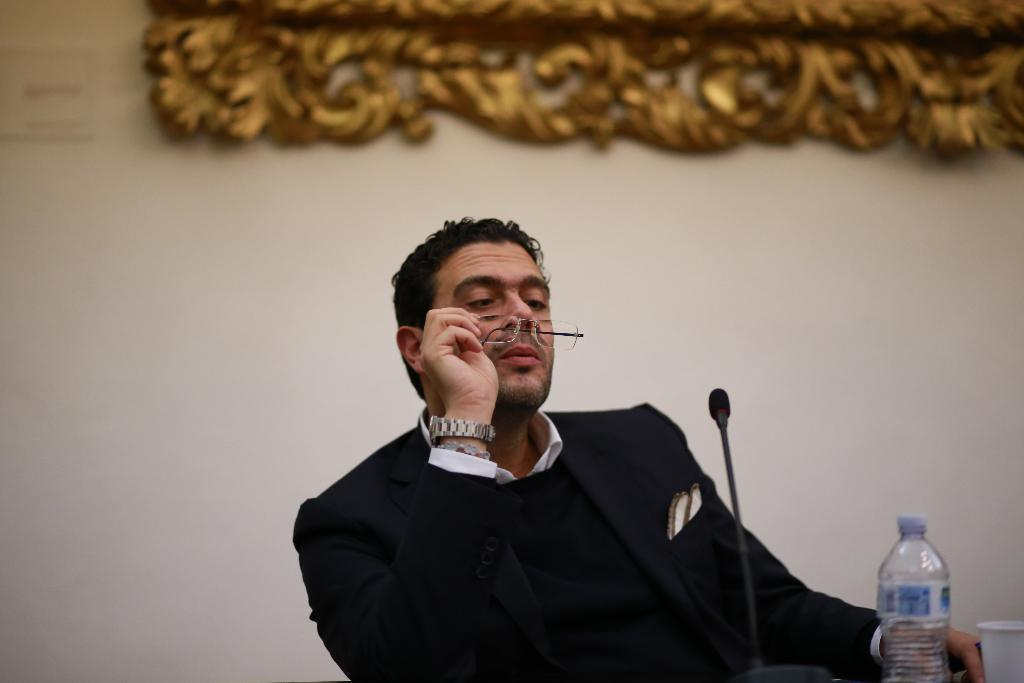What is the person in the image doing? The person is sitting in the image. What is the person holding in his hand? The person is holding glasses and a watch in his hand. What is the person wearing? The person is wearing a suit. What other objects can be seen in the image? There is a milk container, a bottle, and a cup in the image. Can you see a cake on the seashore in the image? There is no cake or seashore present in the image. 